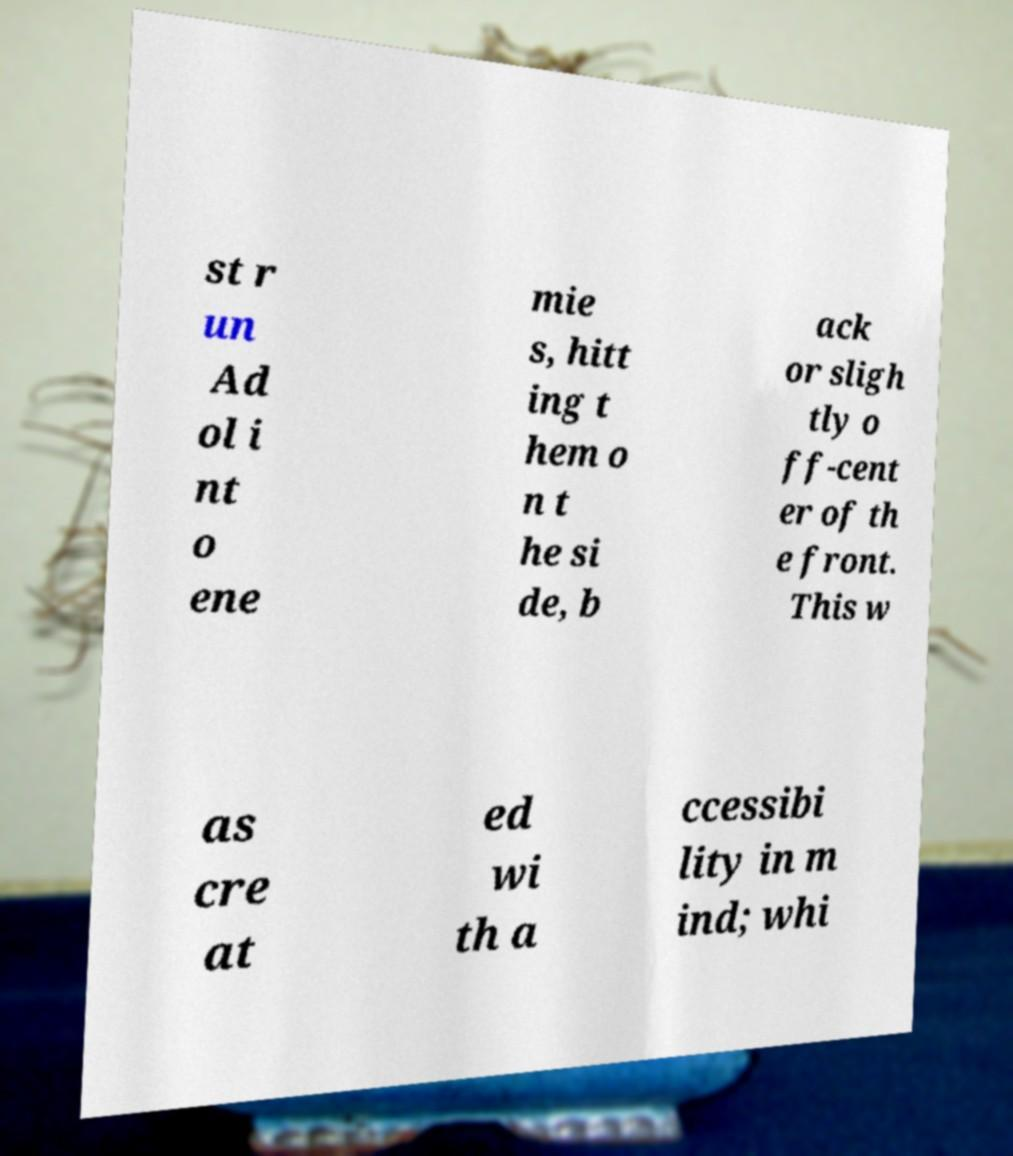Could you assist in decoding the text presented in this image and type it out clearly? st r un Ad ol i nt o ene mie s, hitt ing t hem o n t he si de, b ack or sligh tly o ff-cent er of th e front. This w as cre at ed wi th a ccessibi lity in m ind; whi 